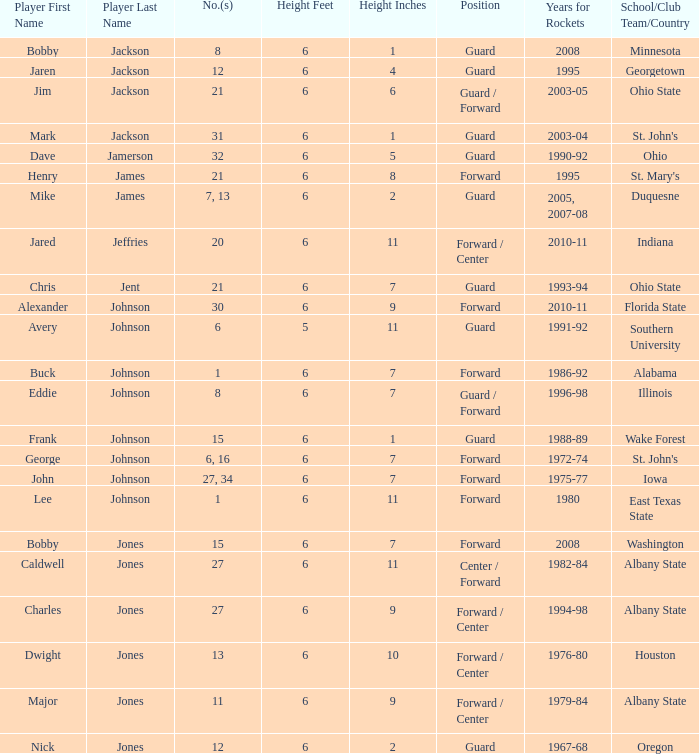What is the number of the player who went to Southern University? 6.0. 